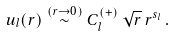Convert formula to latex. <formula><loc_0><loc_0><loc_500><loc_500>u _ { l } ( r ) \stackrel { ( r \rightarrow 0 ) } { \sim } C ^ { ( + ) } _ { l } \, \sqrt { r } \, r ^ { s _ { l } } \, .</formula> 